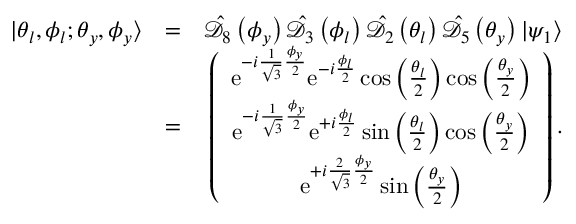<formula> <loc_0><loc_0><loc_500><loc_500>\begin{array} { r l r } { | \theta _ { l } , \phi _ { l } ; \theta _ { y } , \phi _ { y } \rangle } & { = } & { \hat { \mathcal { D } } _ { 8 } \left ( \phi _ { y } \right ) \hat { \mathcal { D } } _ { 3 } \left ( \phi _ { l } \right ) \hat { \mathcal { D } } _ { 2 } \left ( \theta _ { l } \right ) \hat { \mathcal { D } } _ { 5 } \left ( \theta _ { y } \right ) | \psi _ { 1 } \rangle } \\ & { = } & { \left ( \begin{array} { c } { e ^ { - i \frac { 1 } { \sqrt { 3 } } \frac { \phi _ { y } } { 2 } } e ^ { - i \frac { \phi _ { l } } { 2 } } \cos \left ( \frac { \theta _ { l } } { 2 } \right ) \cos \left ( \frac { \theta _ { y } } { 2 } \right ) } \\ { e ^ { - i \frac { 1 } { \sqrt { 3 } } \frac { \phi _ { y } } { 2 } } e ^ { + i \frac { \phi _ { l } } { 2 } } \sin \left ( \frac { \theta _ { l } } { 2 } \right ) \cos \left ( \frac { \theta _ { y } } { 2 } \right ) } \\ { e ^ { + i \frac { 2 } { \sqrt { 3 } } \frac { \phi _ { y } } { 2 } } \sin \left ( \frac { \theta _ { y } } { 2 } \right ) } \end{array} \right ) . } \end{array}</formula> 